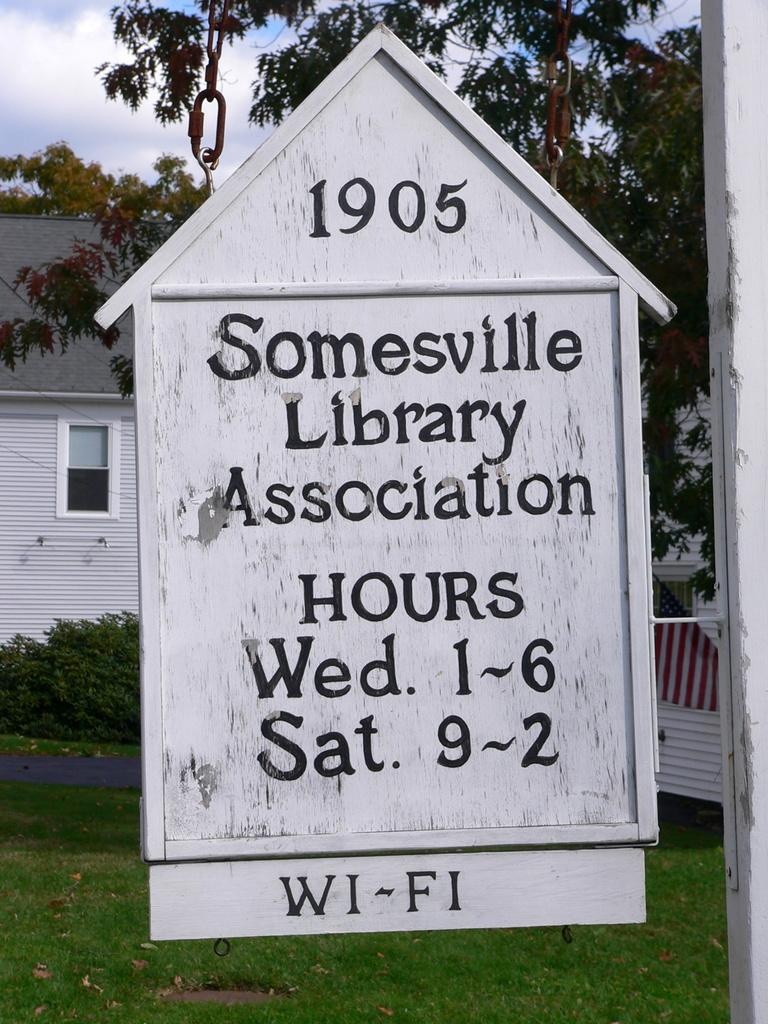What is the main object in the image? There is a board with chains in the image. What can be found on the board? There is information on the board. What type of natural environment is visible in the image? There is grass visible in the image. What can be seen in the background of the image? There are trees, houses, plants, and the sky visible in the background of the image. What is the condition of the sky in the image? The sky is visible in the background of the image, and there are clouds present. What type of poison is being used to help the rod in the image? There is no rod, poison, or any indication of assistance in the image. 